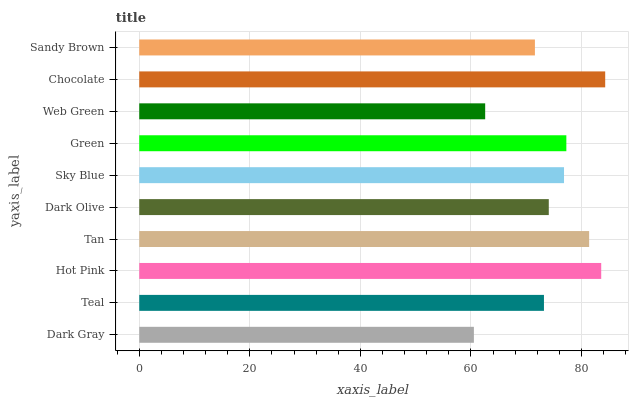Is Dark Gray the minimum?
Answer yes or no. Yes. Is Chocolate the maximum?
Answer yes or no. Yes. Is Teal the minimum?
Answer yes or no. No. Is Teal the maximum?
Answer yes or no. No. Is Teal greater than Dark Gray?
Answer yes or no. Yes. Is Dark Gray less than Teal?
Answer yes or no. Yes. Is Dark Gray greater than Teal?
Answer yes or no. No. Is Teal less than Dark Gray?
Answer yes or no. No. Is Sky Blue the high median?
Answer yes or no. Yes. Is Dark Olive the low median?
Answer yes or no. Yes. Is Tan the high median?
Answer yes or no. No. Is Sky Blue the low median?
Answer yes or no. No. 